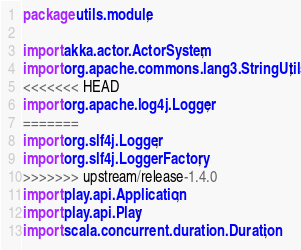Convert code to text. <code><loc_0><loc_0><loc_500><loc_500><_Java_>package utils.module;

import akka.actor.ActorSystem;
import org.apache.commons.lang3.StringUtils;
<<<<<<< HEAD
import org.apache.log4j.Logger;
=======
import org.slf4j.Logger;
import org.slf4j.LoggerFactory;
>>>>>>> upstream/release-1.4.0
import play.api.Application;
import play.api.Play;
import scala.concurrent.duration.Duration;</code> 